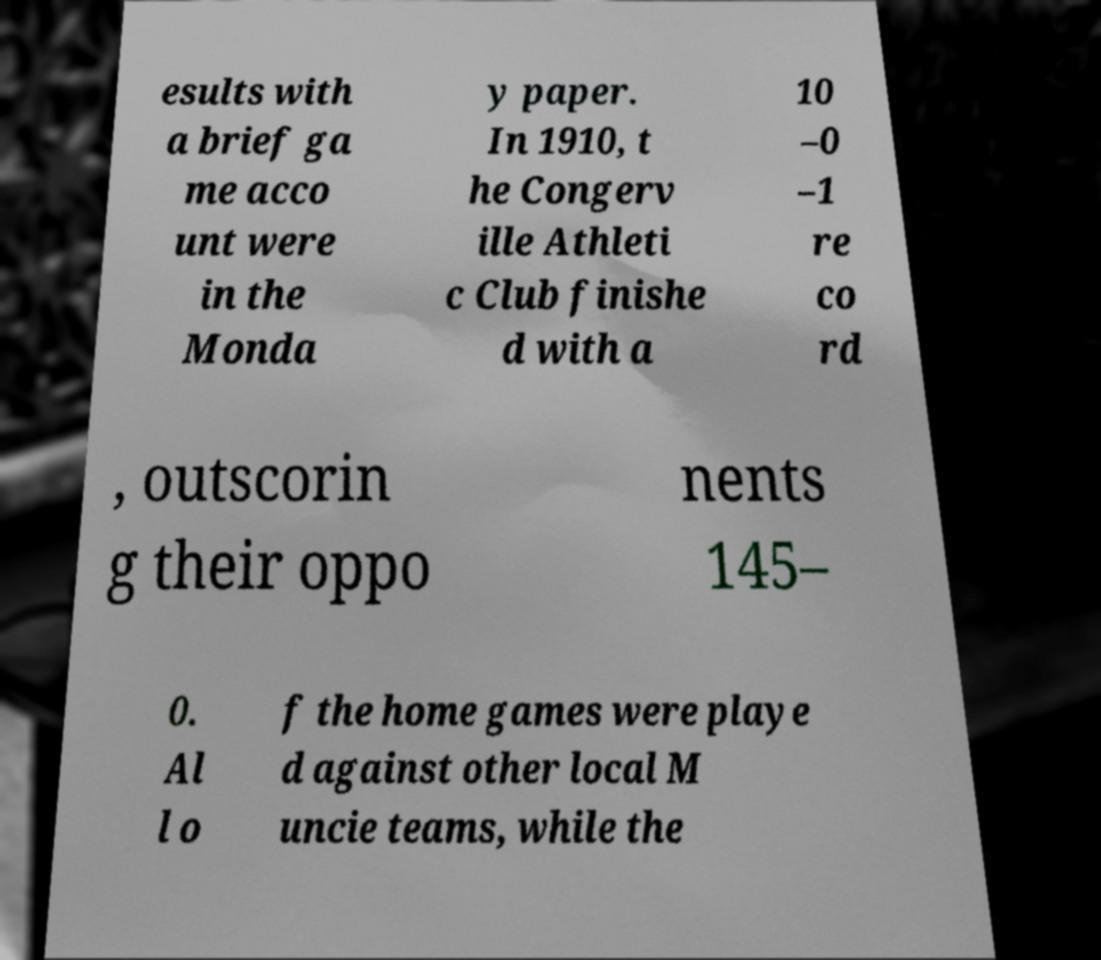There's text embedded in this image that I need extracted. Can you transcribe it verbatim? esults with a brief ga me acco unt were in the Monda y paper. In 1910, t he Congerv ille Athleti c Club finishe d with a 10 –0 –1 re co rd , outscorin g their oppo nents 145– 0. Al l o f the home games were playe d against other local M uncie teams, while the 